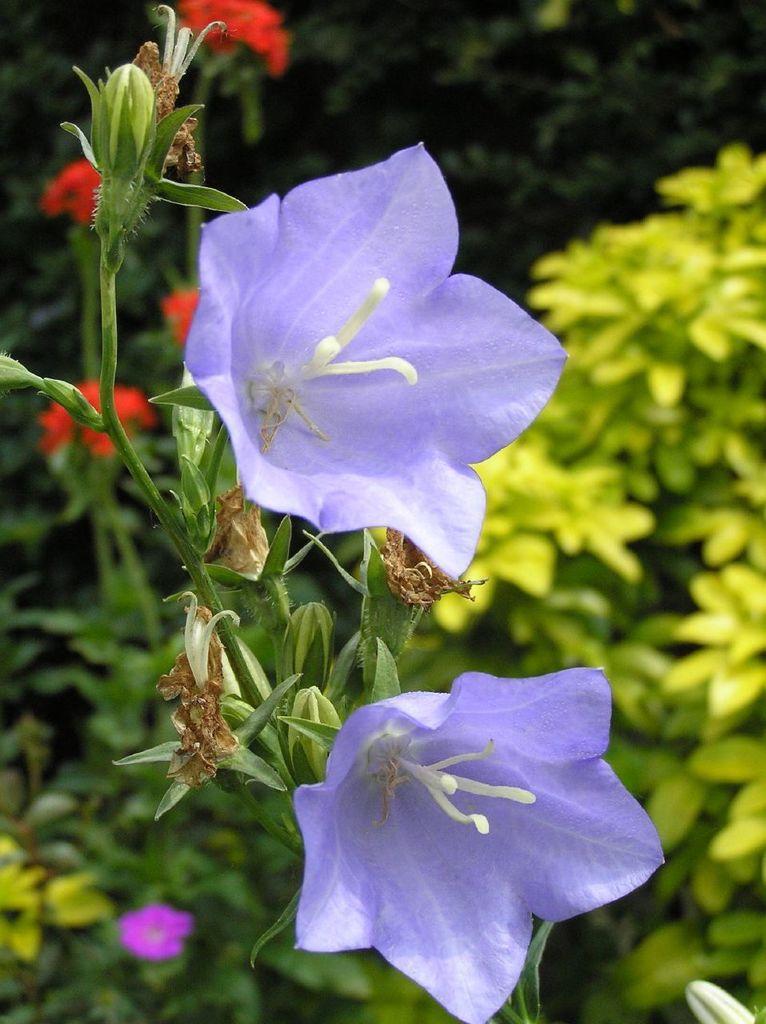In one or two sentences, can you explain what this image depicts? There are 2 blue balloons flowers and other flower plants behind it. 